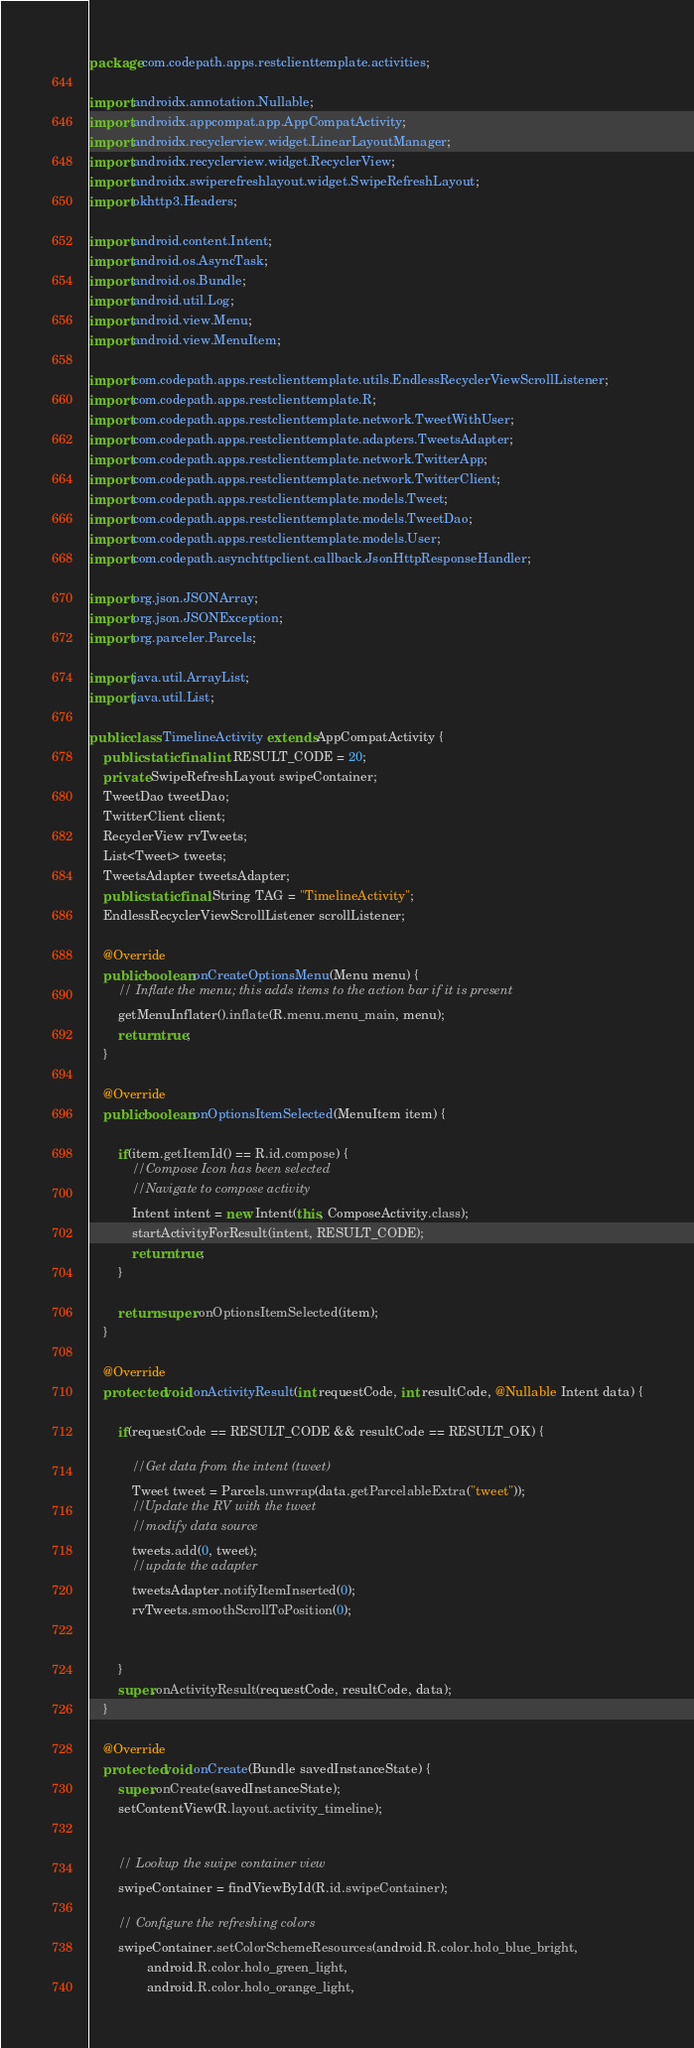Convert code to text. <code><loc_0><loc_0><loc_500><loc_500><_Java_>package com.codepath.apps.restclienttemplate.activities;

import androidx.annotation.Nullable;
import androidx.appcompat.app.AppCompatActivity;
import androidx.recyclerview.widget.LinearLayoutManager;
import androidx.recyclerview.widget.RecyclerView;
import androidx.swiperefreshlayout.widget.SwipeRefreshLayout;
import okhttp3.Headers;

import android.content.Intent;
import android.os.AsyncTask;
import android.os.Bundle;
import android.util.Log;
import android.view.Menu;
import android.view.MenuItem;

import com.codepath.apps.restclienttemplate.utils.EndlessRecyclerViewScrollListener;
import com.codepath.apps.restclienttemplate.R;
import com.codepath.apps.restclienttemplate.network.TweetWithUser;
import com.codepath.apps.restclienttemplate.adapters.TweetsAdapter;
import com.codepath.apps.restclienttemplate.network.TwitterApp;
import com.codepath.apps.restclienttemplate.network.TwitterClient;
import com.codepath.apps.restclienttemplate.models.Tweet;
import com.codepath.apps.restclienttemplate.models.TweetDao;
import com.codepath.apps.restclienttemplate.models.User;
import com.codepath.asynchttpclient.callback.JsonHttpResponseHandler;

import org.json.JSONArray;
import org.json.JSONException;
import org.parceler.Parcels;

import java.util.ArrayList;
import java.util.List;

public class TimelineActivity extends AppCompatActivity {
    public static final int RESULT_CODE = 20;
    private SwipeRefreshLayout swipeContainer;
    TweetDao tweetDao;
    TwitterClient client;
    RecyclerView rvTweets;
    List<Tweet> tweets;
    TweetsAdapter tweetsAdapter;
    public static final String TAG = "TimelineActivity";
    EndlessRecyclerViewScrollListener scrollListener;

    @Override
    public boolean onCreateOptionsMenu(Menu menu) {
        // Inflate the menu; this adds items to the action bar if it is present
        getMenuInflater().inflate(R.menu.menu_main, menu);
        return true;
    }

    @Override
    public boolean onOptionsItemSelected(MenuItem item) {

        if(item.getItemId() == R.id.compose) {
            //Compose Icon has been selected
            //Navigate to compose activity
            Intent intent = new Intent(this, ComposeActivity.class);
            startActivityForResult(intent, RESULT_CODE);
            return true;
        }

        return super.onOptionsItemSelected(item);
    }

    @Override
    protected void onActivityResult(int requestCode, int resultCode, @Nullable Intent data) {

        if(requestCode == RESULT_CODE && resultCode == RESULT_OK) {

            //Get data from the intent (tweet)
            Tweet tweet = Parcels.unwrap(data.getParcelableExtra("tweet"));
            //Update the RV with the tweet
            //modify data source
            tweets.add(0, tweet);
            //update the adapter
            tweetsAdapter.notifyItemInserted(0);
            rvTweets.smoothScrollToPosition(0);


        }
        super.onActivityResult(requestCode, resultCode, data);
    }

    @Override
    protected void onCreate(Bundle savedInstanceState) {
        super.onCreate(savedInstanceState);
        setContentView(R.layout.activity_timeline);


        // Lookup the swipe container view
        swipeContainer = findViewById(R.id.swipeContainer);

        // Configure the refreshing colors
        swipeContainer.setColorSchemeResources(android.R.color.holo_blue_bright,
                android.R.color.holo_green_light,
                android.R.color.holo_orange_light,</code> 